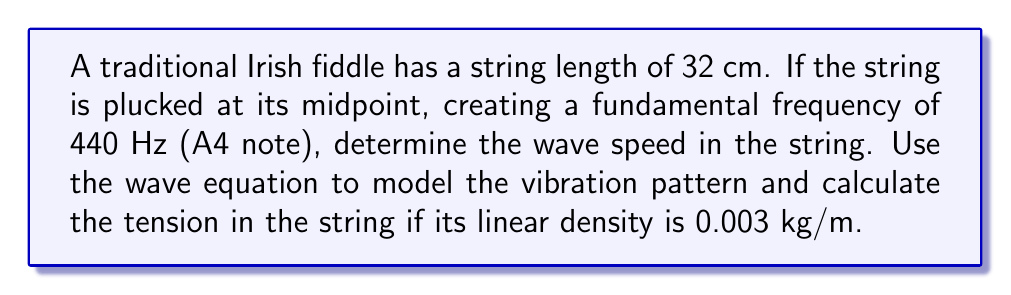Provide a solution to this math problem. Let's approach this step-by-step:

1) The wave equation for a vibrating string is:

   $$\frac{\partial^2 y}{\partial t^2} = v^2 \frac{\partial^2 y}{\partial x^2}$$

   where $v$ is the wave speed.

2) For a string fixed at both ends, the fundamental frequency $f$ is related to the string length $L$ and wave speed $v$ by:

   $$f = \frac{v}{2L}$$

3) We can rearrange this to find the wave speed:

   $$v = 2fL$$

4) Substituting the given values:

   $$v = 2 \cdot 440 \text{ Hz} \cdot 0.32 \text{ m} = 281.6 \text{ m/s}$$

5) Now, to find the tension, we can use the relationship between wave speed, tension $T$, and linear density $\mu$:

   $$v = \sqrt{\frac{T}{\mu}}$$

6) Rearranging to solve for tension:

   $$T = v^2\mu$$

7) Substituting the values:

   $$T = (281.6 \text{ m/s})^2 \cdot 0.003 \text{ kg/m} = 237.9 \text{ N}$$

8) The vibration pattern can be modeled using the wave equation solution:

   $$y(x,t) = A \sin(\frac{\pi x}{L}) \cos(2\pi ft)$$

   where $A$ is the amplitude, $x$ is the position along the string, and $t$ is time.
Answer: Wave speed: 281.6 m/s; Tension: 237.9 N 